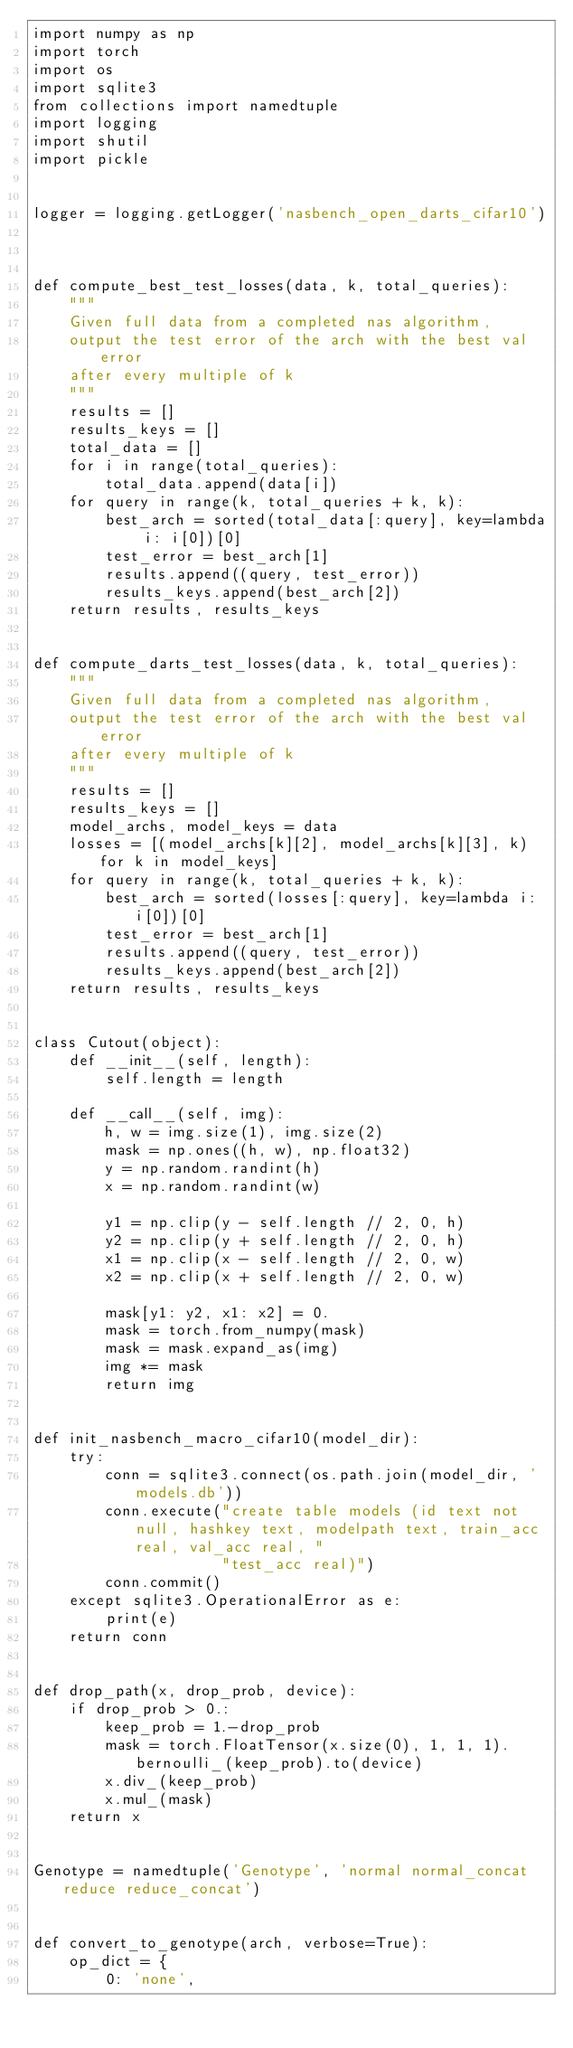<code> <loc_0><loc_0><loc_500><loc_500><_Python_>import numpy as np
import torch
import os
import sqlite3
from collections import namedtuple
import logging
import shutil
import pickle


logger = logging.getLogger('nasbench_open_darts_cifar10')



def compute_best_test_losses(data, k, total_queries):
    """
    Given full data from a completed nas algorithm,
    output the test error of the arch with the best val error
    after every multiple of k
    """
    results = []
    results_keys = []
    total_data = []
    for i in range(total_queries):
        total_data.append(data[i])
    for query in range(k, total_queries + k, k):
        best_arch = sorted(total_data[:query], key=lambda i: i[0])[0]
        test_error = best_arch[1]
        results.append((query, test_error))
        results_keys.append(best_arch[2])
    return results, results_keys


def compute_darts_test_losses(data, k, total_queries):
    """
    Given full data from a completed nas algorithm,
    output the test error of the arch with the best val error
    after every multiple of k
    """
    results = []
    results_keys = []
    model_archs, model_keys = data
    losses = [(model_archs[k][2], model_archs[k][3], k) for k in model_keys]
    for query in range(k, total_queries + k, k):
        best_arch = sorted(losses[:query], key=lambda i: i[0])[0]
        test_error = best_arch[1]
        results.append((query, test_error))
        results_keys.append(best_arch[2])
    return results, results_keys


class Cutout(object):
    def __init__(self, length):
        self.length = length

    def __call__(self, img):
        h, w = img.size(1), img.size(2)
        mask = np.ones((h, w), np.float32)
        y = np.random.randint(h)
        x = np.random.randint(w)

        y1 = np.clip(y - self.length // 2, 0, h)
        y2 = np.clip(y + self.length // 2, 0, h)
        x1 = np.clip(x - self.length // 2, 0, w)
        x2 = np.clip(x + self.length // 2, 0, w)

        mask[y1: y2, x1: x2] = 0.
        mask = torch.from_numpy(mask)
        mask = mask.expand_as(img)
        img *= mask
        return img


def init_nasbench_macro_cifar10(model_dir):
    try:
        conn = sqlite3.connect(os.path.join(model_dir, 'models.db'))
        conn.execute("create table models (id text not null, hashkey text, modelpath text, train_acc real, val_acc real, "
                     "test_acc real)")
        conn.commit()
    except sqlite3.OperationalError as e:
        print(e)
    return conn


def drop_path(x, drop_prob, device):
    if drop_prob > 0.:
        keep_prob = 1.-drop_prob
        mask = torch.FloatTensor(x.size(0), 1, 1, 1).bernoulli_(keep_prob).to(device)
        x.div_(keep_prob)
        x.mul_(mask)
    return x


Genotype = namedtuple('Genotype', 'normal normal_concat reduce reduce_concat')


def convert_to_genotype(arch, verbose=True):
    op_dict = {
        0: 'none',</code> 